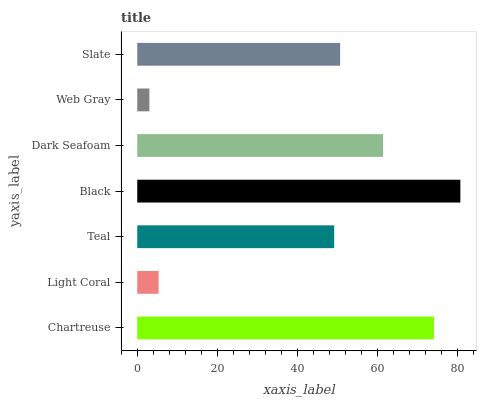Is Web Gray the minimum?
Answer yes or no. Yes. Is Black the maximum?
Answer yes or no. Yes. Is Light Coral the minimum?
Answer yes or no. No. Is Light Coral the maximum?
Answer yes or no. No. Is Chartreuse greater than Light Coral?
Answer yes or no. Yes. Is Light Coral less than Chartreuse?
Answer yes or no. Yes. Is Light Coral greater than Chartreuse?
Answer yes or no. No. Is Chartreuse less than Light Coral?
Answer yes or no. No. Is Slate the high median?
Answer yes or no. Yes. Is Slate the low median?
Answer yes or no. Yes. Is Black the high median?
Answer yes or no. No. Is Dark Seafoam the low median?
Answer yes or no. No. 